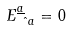<formula> <loc_0><loc_0><loc_500><loc_500>E ^ { \underline { a } } _ { \hat { \ a } } = 0</formula> 